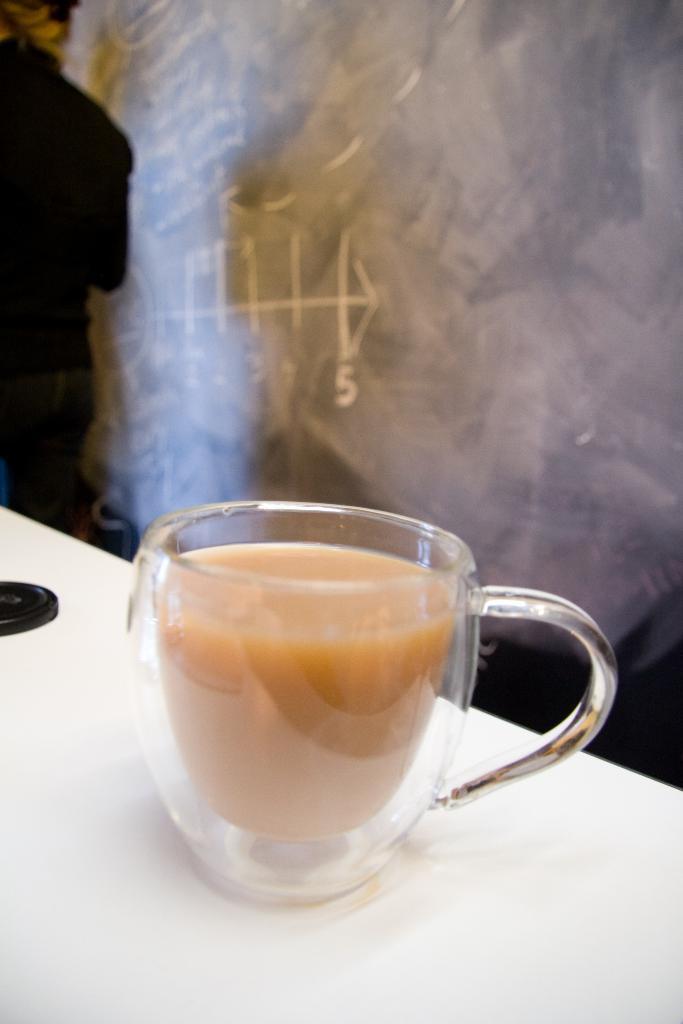How would you summarize this image in a sentence or two? In the center we can see coffee cup on the table. On the back we can see one person standing and wall. 